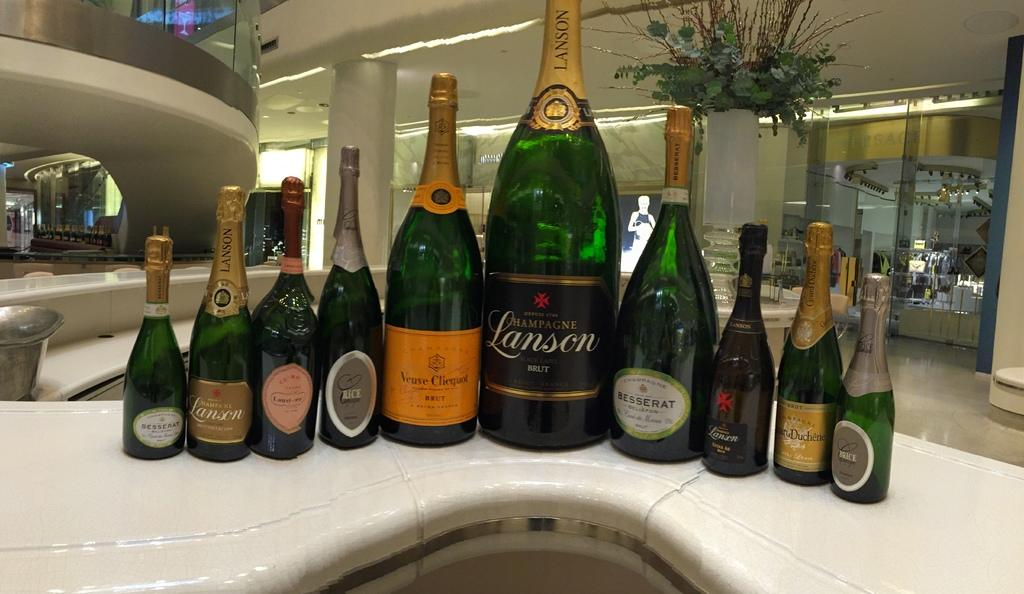<image>
Render a clear and concise summary of the photo. Ten champagne's bottles sit on a counter of which one is a Lanson. 